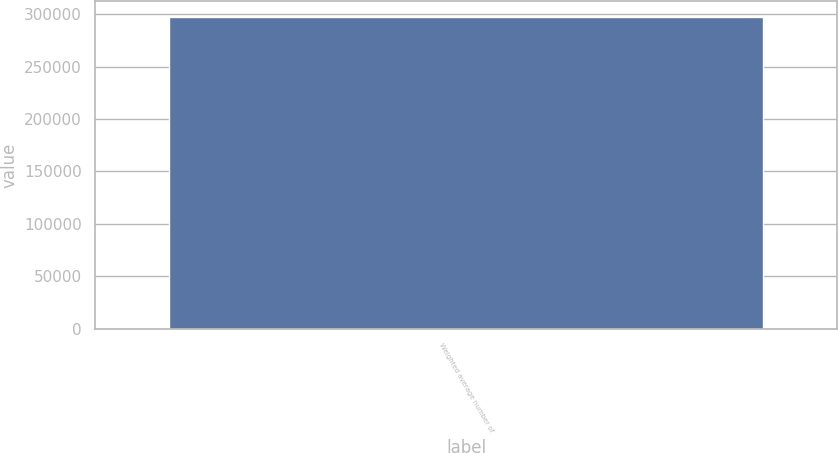Convert chart. <chart><loc_0><loc_0><loc_500><loc_500><bar_chart><fcel>Weighted average number of<nl><fcel>297582<nl></chart> 